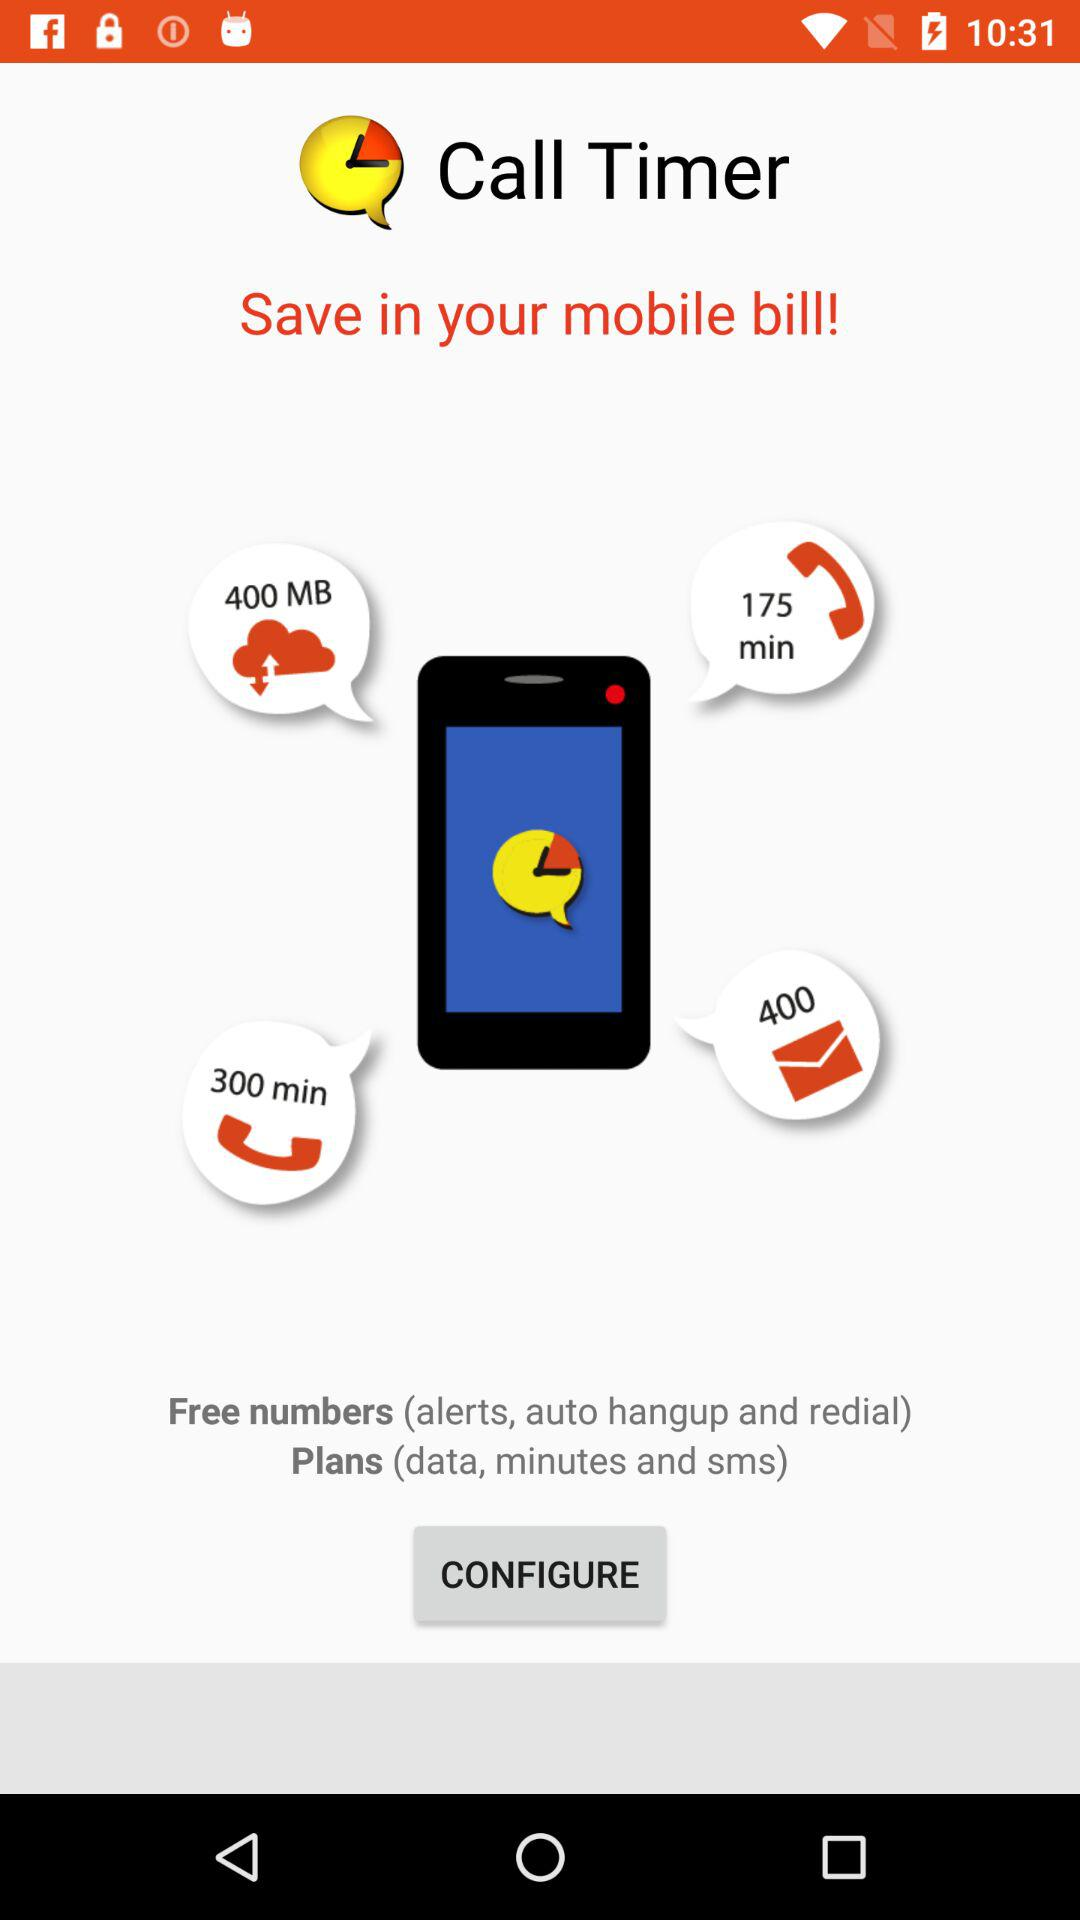How many SMS are there? There are 400 SMS. 